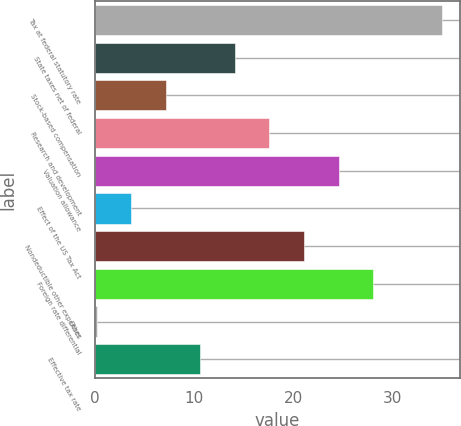<chart> <loc_0><loc_0><loc_500><loc_500><bar_chart><fcel>Tax at federal statutory rate<fcel>State taxes net of federal<fcel>Stock-based compensation<fcel>Research and development<fcel>Valuation allowance<fcel>Effect of the US Tax Act<fcel>Nondeductible other expenses<fcel>Foreign rate differential<fcel>Other<fcel>Effective tax rate<nl><fcel>35<fcel>14.12<fcel>7.16<fcel>17.6<fcel>24.56<fcel>3.68<fcel>21.08<fcel>28.04<fcel>0.2<fcel>10.64<nl></chart> 